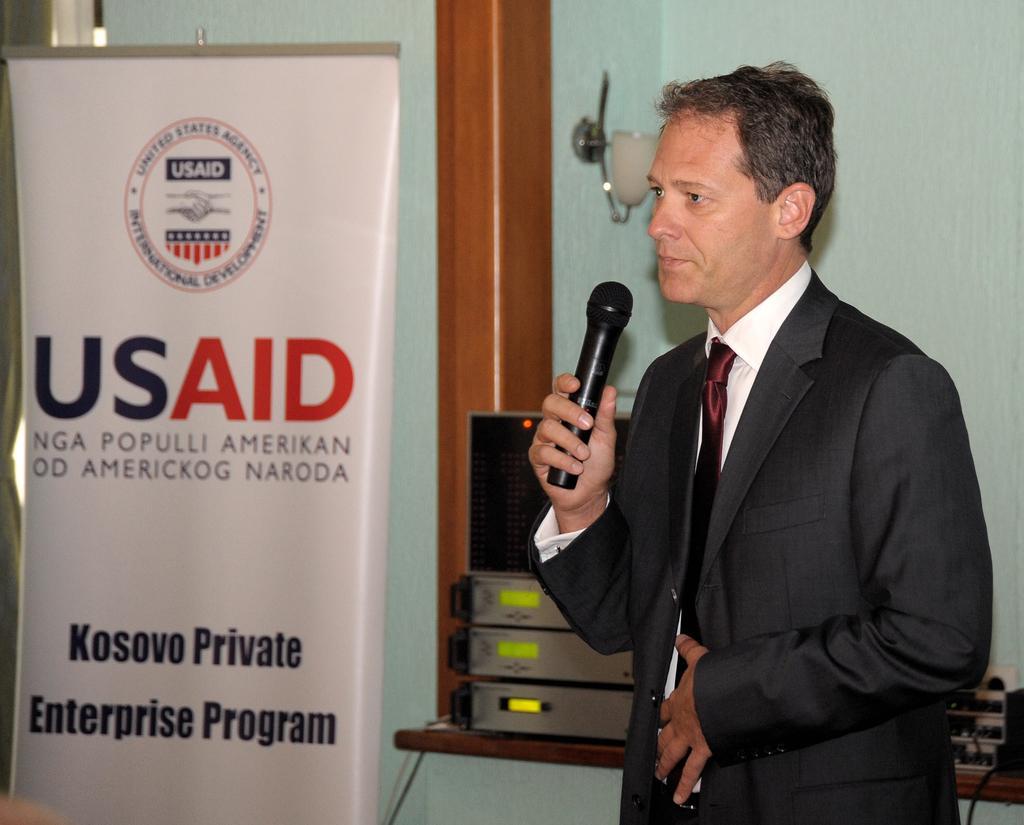In one or two sentences, can you explain what this image depicts? There is a man who is holding a mike with his hand. He is in a suit. There is a banner. On the background there is a wall and these are some electronic devices. 